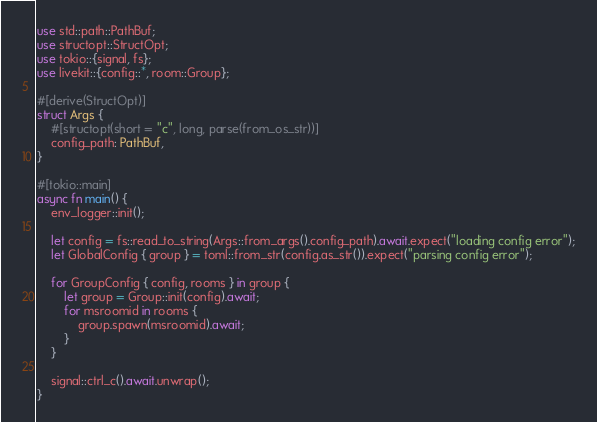Convert code to text. <code><loc_0><loc_0><loc_500><loc_500><_Rust_>use std::path::PathBuf;
use structopt::StructOpt;
use tokio::{signal, fs};
use livekit::{config::*, room::Group};

#[derive(StructOpt)]
struct Args {
    #[structopt(short = "c", long, parse(from_os_str))]
    config_path: PathBuf,
}

#[tokio::main]
async fn main() {
    env_logger::init();

    let config = fs::read_to_string(Args::from_args().config_path).await.expect("loading config error");
    let GlobalConfig { group } = toml::from_str(config.as_str()).expect("parsing config error");

    for GroupConfig { config, rooms } in group {
        let group = Group::init(config).await;
        for msroomid in rooms {
            group.spawn(msroomid).await;
        }
    }

    signal::ctrl_c().await.unwrap();
}
</code> 